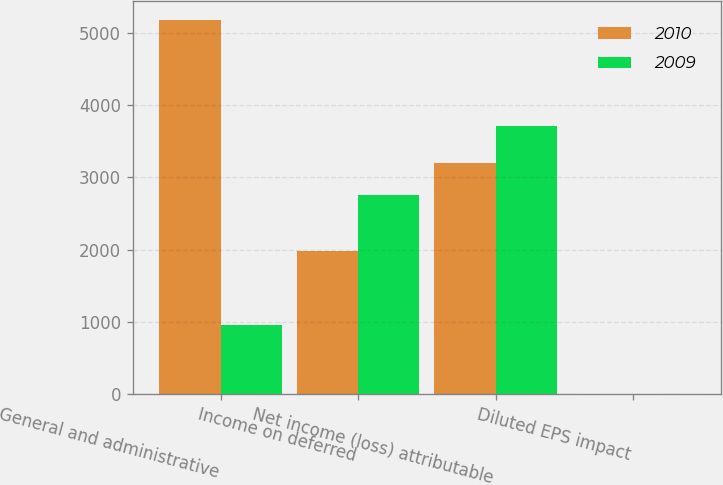<chart> <loc_0><loc_0><loc_500><loc_500><stacked_bar_chart><ecel><fcel>General and administrative<fcel>Income on deferred<fcel>Net income (loss) attributable<fcel>Diluted EPS impact<nl><fcel>2010<fcel>5180<fcel>1982<fcel>3198<fcel>0.04<nl><fcel>2009<fcel>956<fcel>2750<fcel>3706<fcel>0.05<nl></chart> 